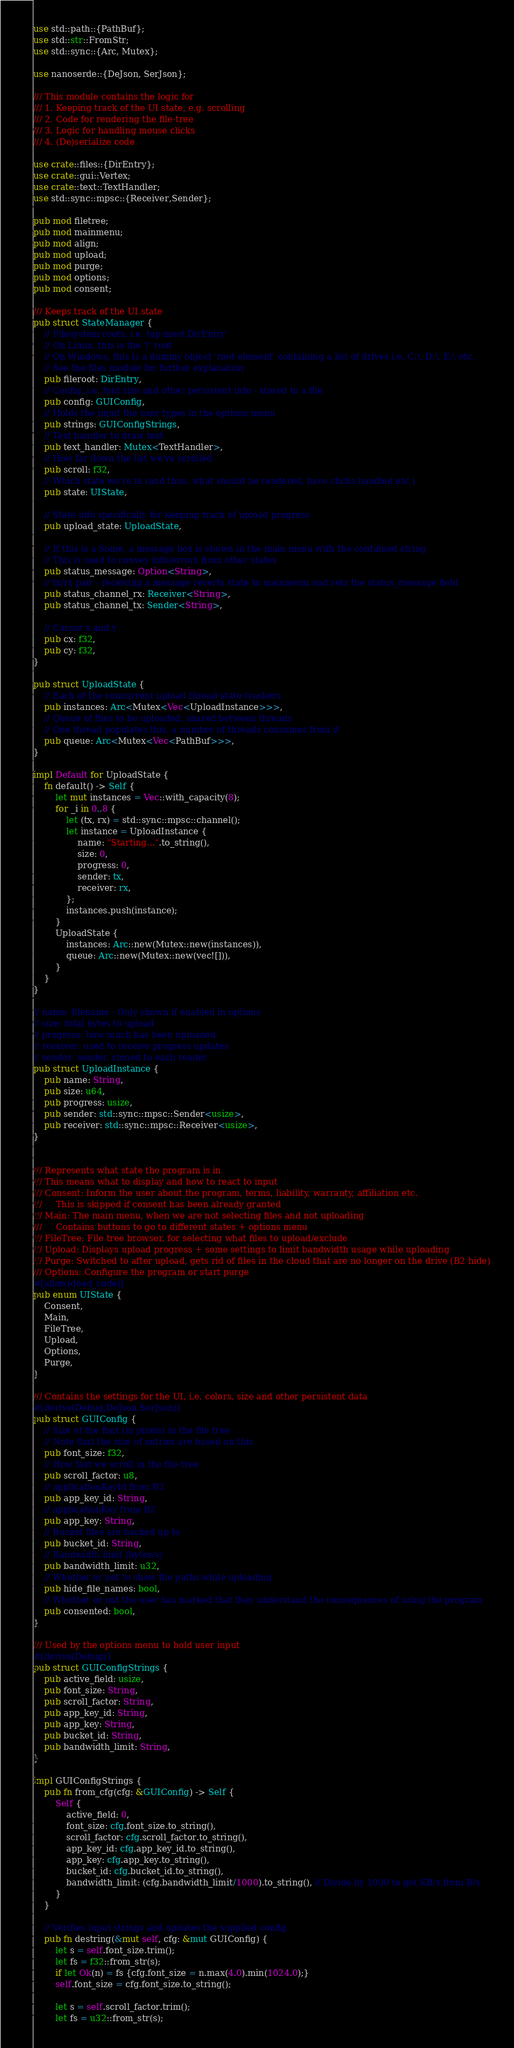<code> <loc_0><loc_0><loc_500><loc_500><_Rust_>use std::path::{PathBuf};
use std::str::FromStr;
use std::sync::{Arc, Mutex};

use nanoserde::{DeJson, SerJson};

/// This module contains the logic for
/// 1. Keeping track of the UI state, e.g. scrolling
/// 2. Code for rendering the file-tree
/// 3. Logic for handling mouse clicks
/// 4. (De)serialize code

use crate::files::{DirEntry};
use crate::gui::Vertex;
use crate::text::TextHandler;
use std::sync::mpsc::{Receiver,Sender};

pub mod filetree;
pub mod mainmenu;
pub mod align;
pub mod upload;
pub mod purge;
pub mod options;
pub mod consent;

/// Keeps track of the UI state
pub struct StateManager {
    // Filesystem roots, i.e. top-most DirEntry
    // On Linux, this is the '/' root
    // On Windows, this is a dummy object 'root element' containing a list of drives i.e. C:\, D:\, E:\ etc.
    // See the files module for further explanation
    pub fileroot: DirEntry,
    // Config, i.e. font size and other persistent info - stored to a file
    pub config: GUIConfig,
    // Holds the input the user types in the options menu
    pub strings: GUIConfigStrings,
    // Text handler to draw text
    pub text_handler: Mutex<TextHandler>,
    // How far down the list we've scrolled
    pub scroll: f32,
    // Which state we're in (and thus, what should be rendered, have clicks handled etc.)
    pub state: UIState,

    // State info specifically for keeping track of upload progress
    pub upload_state: UploadState,

    // If this is a Some, a message box is shown in the main menu with the contained string
    // This is used to convey info/errors from other states
    pub status_message: Option<String>,
    // tx/rx pair - receiving a message reverts state to mainmenu and sets the status_message field
    pub status_channel_rx: Receiver<String>,
    pub status_channel_tx: Sender<String>,

    // Cursor x and y
    pub cx: f32,
    pub cy: f32,
}

pub struct UploadState {
    // Each of the concurrent upload thread state trackers
    pub instances: Arc<Mutex<Vec<UploadInstance>>>,
    // Queue of files to be uploaded, shared between threads
    // One thread populates this, a number of threads consumes from it
    pub queue: Arc<Mutex<Vec<PathBuf>>>,
}

impl Default for UploadState {
    fn default() -> Self {
        let mut instances = Vec::with_capacity(8);
        for _i in 0..8 {
            let (tx, rx) = std::sync::mpsc::channel();
            let instance = UploadInstance {
                name: "Starting...".to_string(),
                size: 0,
                progress: 0,
                sender: tx,
                receiver: rx,
            };
            instances.push(instance);
        }
        UploadState {
            instances: Arc::new(Mutex::new(instances)),
            queue: Arc::new(Mutex::new(vec![])),
        }
    }
}

// name: filename - Only shown if enabled in options
// size: total bytes to upload
// progress: how much has been uploaded
// receiver: used to receive progress updates
// sender: sender, cloned to each reader
pub struct UploadInstance {
    pub name: String,
    pub size: u64,
    pub progress: usize,
    pub sender: std::sync::mpsc::Sender<usize>,
    pub receiver: std::sync::mpsc::Receiver<usize>,
}


/// Represents what state the program is in
/// This means what to display and how to react to input
/// Consent: Inform the user about the program, terms, liability, warranty, affiliation etc.
///     This is skipped if consent has been already granted
/// Main: The main menu, when we are not selecting files and not uploading
///     Contains buttons to go to different states + options menu
/// FileTree: File tree browser, for selecting what files to upload/exclude
/// Upload: Displays upload progress + some settings to limit bandwidth usage while uploading
/// Purge: Switched to after upload, gets rid of files in the cloud that are no longer on the drive (B2 hide)
/// Options: Configure the program or start purge
#[allow(dead_code)]
pub enum UIState {
    Consent,
    Main,
    FileTree,
    Upload,
    Options,
    Purge,
}

/// Contains the settings for the UI, i.e. colors, size and other persistent data
#[derive(Debug,DeJson,SerJson)]
pub struct GUIConfig {
    // Size of the font (in pixels) in the file tree
    // Note that the size of entries are based on this
    pub font_size: f32,
    // How fast we scroll in the file-tree
    pub scroll_factor: u8,
    // applicationKeyId from B2
    pub app_key_id: String,
    // applicationKey from B2
    pub app_key: String,
    // Bucket files are backed up to
    pub bucket_id: String,
    // Bandwidth limit (bytes/s)
    pub bandwidth_limit: u32,
    // Whether or not to show file paths while uploading
    pub hide_file_names: bool,
    // Whether or not the user has marked that they understand the consequences of using the program
    pub consented: bool,
}

/// Used by the options menu to hold user input
#[derive(Debug)]
pub struct GUIConfigStrings {
    pub active_field: usize,
    pub font_size: String,
    pub scroll_factor: String,
    pub app_key_id: String,
    pub app_key: String,
    pub bucket_id: String,
    pub bandwidth_limit: String,
}

impl GUIConfigStrings {
    pub fn from_cfg(cfg: &GUIConfig) -> Self {
        Self {
            active_field: 0,
            font_size: cfg.font_size.to_string(),
            scroll_factor: cfg.scroll_factor.to_string(),
            app_key_id: cfg.app_key_id.to_string(),
            app_key: cfg.app_key.to_string(),
            bucket_id: cfg.bucket_id.to_string(),
            bandwidth_limit: (cfg.bandwidth_limit/1000).to_string(), // Divide by 1000 to get KB/s from B/s
        }
    }

    // Verifies input strings and updates the supplied config
    pub fn destring(&mut self, cfg: &mut GUIConfig) {
        let s = self.font_size.trim();
        let fs = f32::from_str(s);
        if let Ok(n) = fs {cfg.font_size = n.max(4.0).min(1024.0);}
        self.font_size = cfg.font_size.to_string();

        let s = self.scroll_factor.trim();
        let fs = u32::from_str(s);</code> 